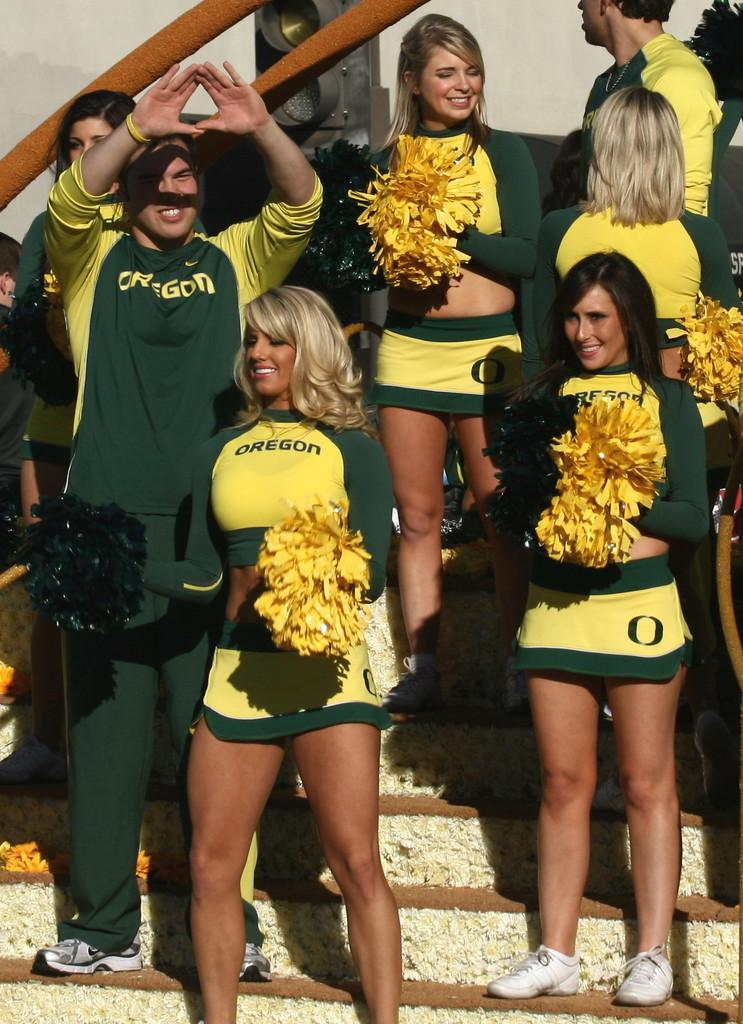<image>
Present a compact description of the photo's key features. Several attractive Oregon cheerleaders wearing green and yellow stand watching the game in front of them. 